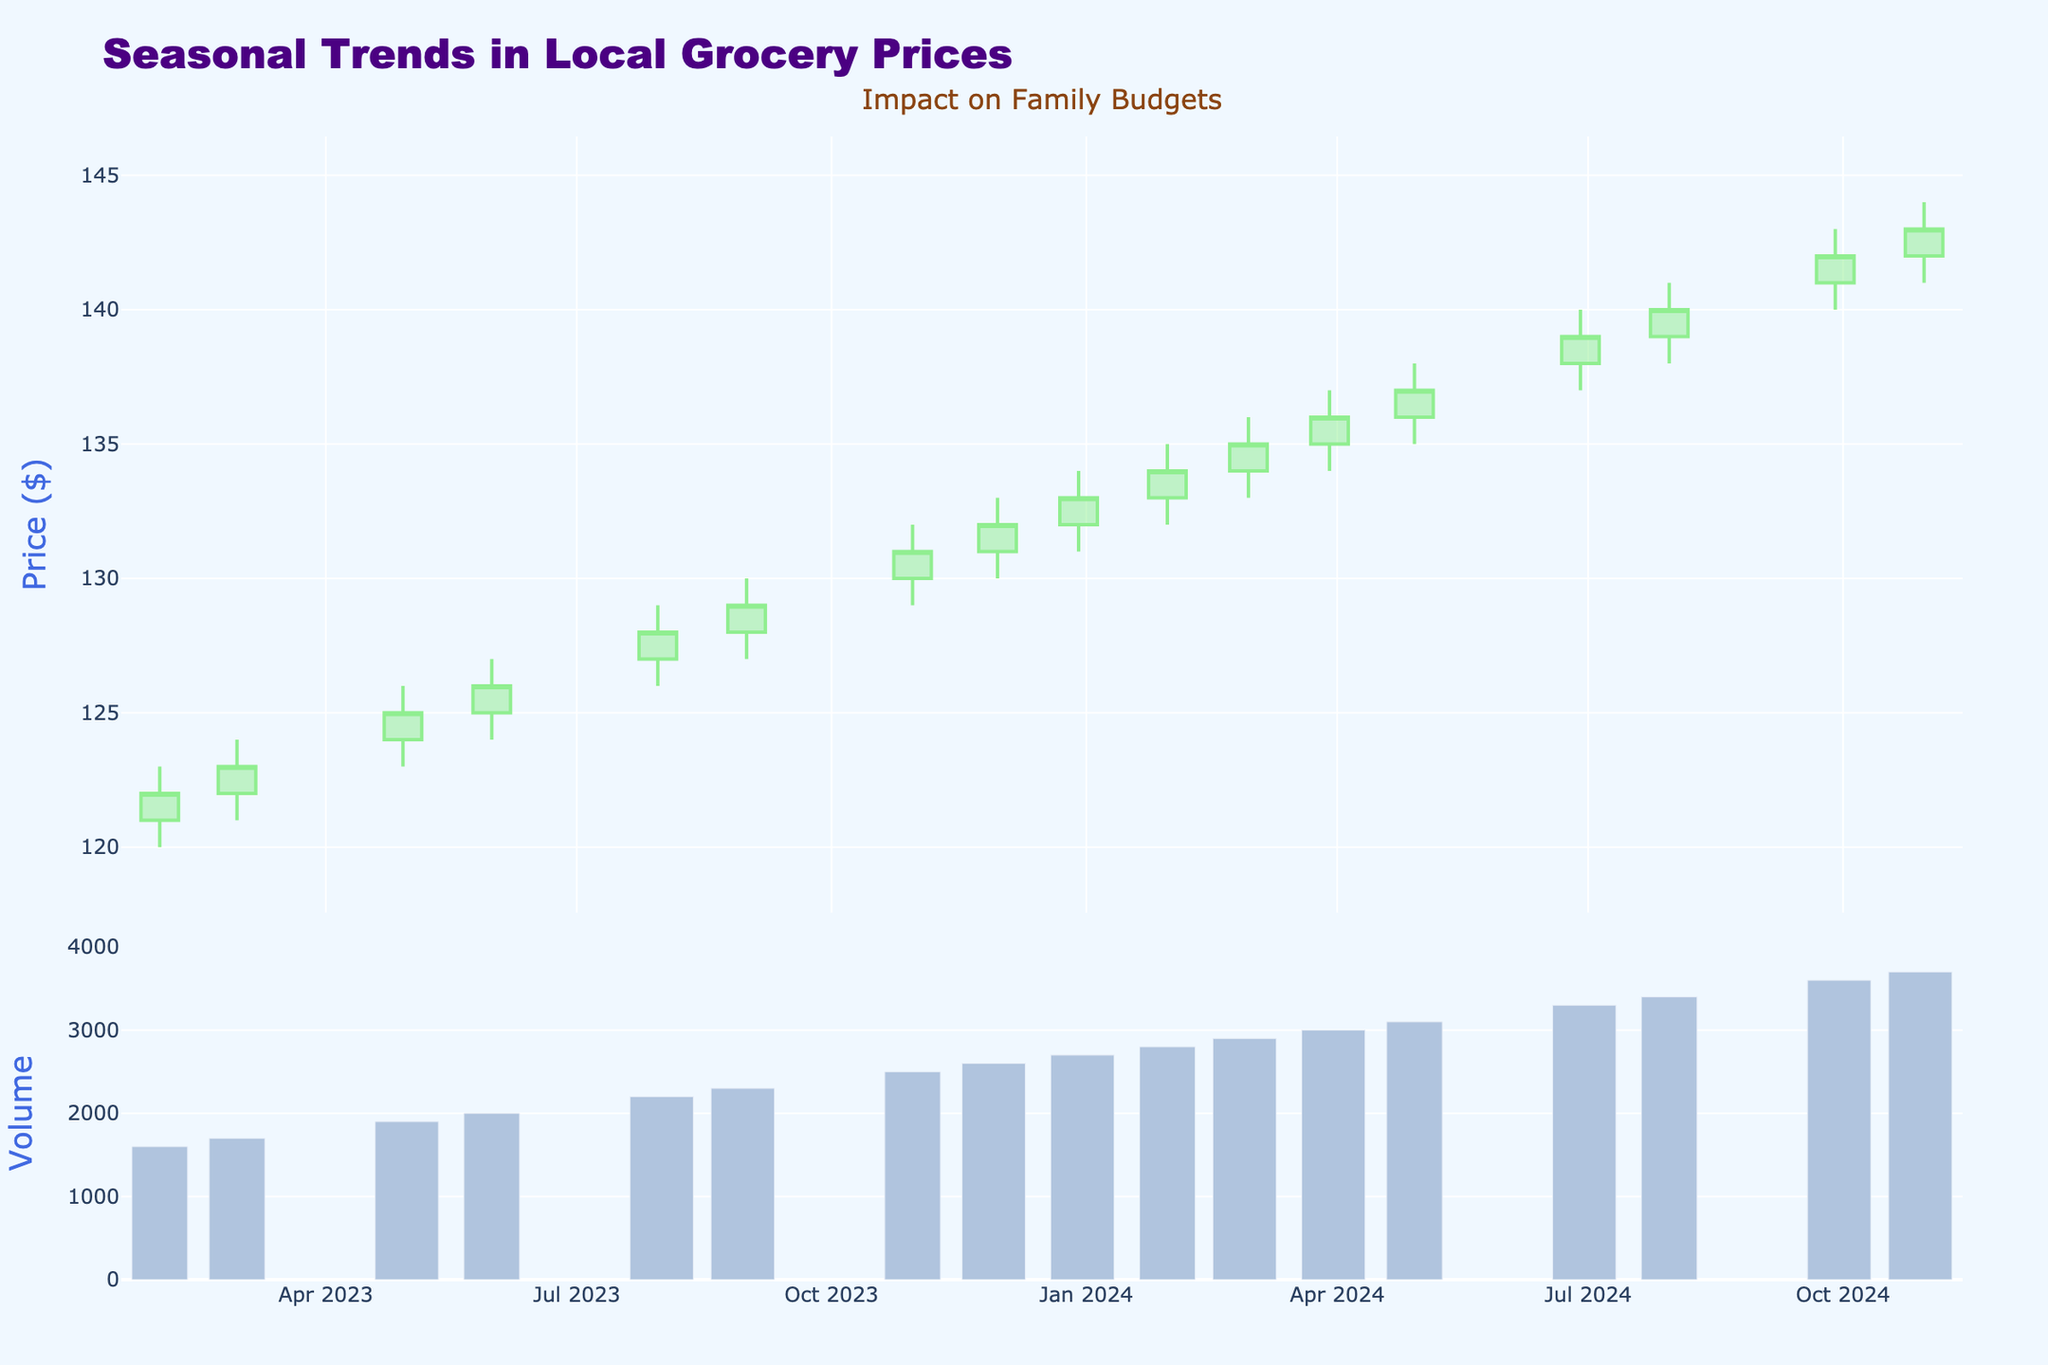How many data points are shown in the figure? The x-axis, labeled with dates, spans from January 2023 to December 2024. Each month displays a single candlestick, resulting in 24 data points.
Answer: 24 What is the title of the figure? The title is prominently displayed at the top of the plot, reading "Seasonal Trends in Local Grocery Prices."
Answer: Seasonal Trends in Local Grocery Prices During which month was the highest trading volume recorded? The bar traces shown in the secondary subplot represent trading volumes. The bar representing December 2024 appears the tallest, indicating the highest volume.
Answer: December 2024 What is the color of the candlestick outlines that indicate a price increase? In the candlestick subplot, upward price movements are represented with light green outlines.
Answer: Light green Which date marks the first recorded price of $130? Referring to the candlesticks, the first instance where the 'Close' value is $130 can be found in September 2023.
Answer: September 2023 Which month showed a decrease in the closing price compared to the previous month? By analyzing the 'Close' values of each month, we notice that the first time this occurs is in February 2024, where the closing price drops from $134 in January to $133 in February.
Answer: February 2024 What is the average closing price for the year 2023? Calculate the average by summing the monthly closing prices for 2023 and dividing by the number of months: (121 + 122 + 123 + 124 + 125 + 126 + 127 + 128 + 129 + 130 + 131 + 132)/12 = 126.5.
Answer: 126.5 In which year did the price experience the highest growth rate from January to December? The growth rate is calculated by the difference between December and January closing prices for each year. For 2023: 132 -121 = 11, and for 2024: 144 - 133 = 11. Both years have the same growth rate of $11.
Answer: Both 2023 and 2024 What is the trend in trading volume from January 2023 to December 2024? Observing the volume bars, there is a consistent increase in volume from January 2023 to December 2024, indicated by progressively taller bars.
Answer: Increasing Which month's closing price is halfway between its highest and lowest price? Using the formula: (High + Low)/2, for example, in July 2023: (128 + 125)/2 = 126.5, which is closest to the closing price of 127. The process reveals July 2023 as the closest fit.
Answer: July 2023 